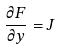Convert formula to latex. <formula><loc_0><loc_0><loc_500><loc_500>\frac { \partial F } { \partial y } = J</formula> 